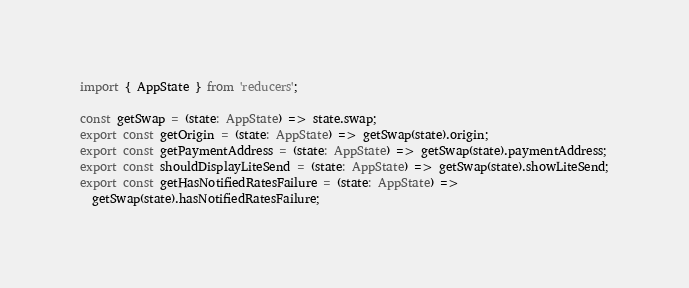Convert code to text. <code><loc_0><loc_0><loc_500><loc_500><_TypeScript_>import { AppState } from 'reducers';

const getSwap = (state: AppState) => state.swap;
export const getOrigin = (state: AppState) => getSwap(state).origin;
export const getPaymentAddress = (state: AppState) => getSwap(state).paymentAddress;
export const shouldDisplayLiteSend = (state: AppState) => getSwap(state).showLiteSend;
export const getHasNotifiedRatesFailure = (state: AppState) =>
  getSwap(state).hasNotifiedRatesFailure;
</code> 